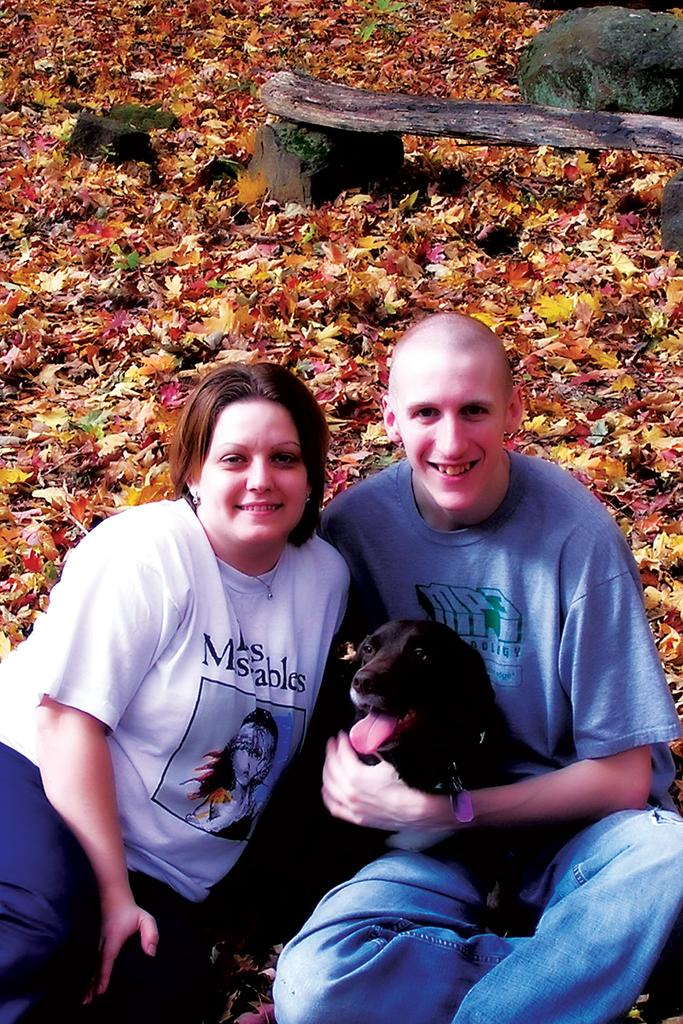How many people are in the image? There are two people in the image. What else can be seen in the image besides the people? There is a dog in the image. Where are the people and the dog located? They are sitting in a garden. Can you describe the man in the image? One of the people is a man, and he is laughing. What type of distribution system is being used for the feast in the image? There is no feast present in the image, so there is no distribution system to discuss. 